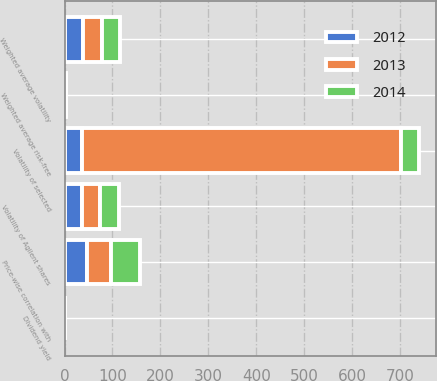Convert chart. <chart><loc_0><loc_0><loc_500><loc_500><stacked_bar_chart><ecel><fcel>Weighted average risk-free<fcel>Dividend yield<fcel>Weighted average volatility<fcel>Volatility of Agilent shares<fcel>Volatility of selected<fcel>Price-wise correlation with<nl><fcel>2012<fcel>1.69<fcel>1<fcel>39<fcel>36<fcel>37.5<fcel>47<nl><fcel>2013<fcel>0.86<fcel>1<fcel>39<fcel>37<fcel>664<fcel>49<nl><fcel>2014<fcel>0.88<fcel>0<fcel>38<fcel>41<fcel>37.5<fcel>62<nl></chart> 